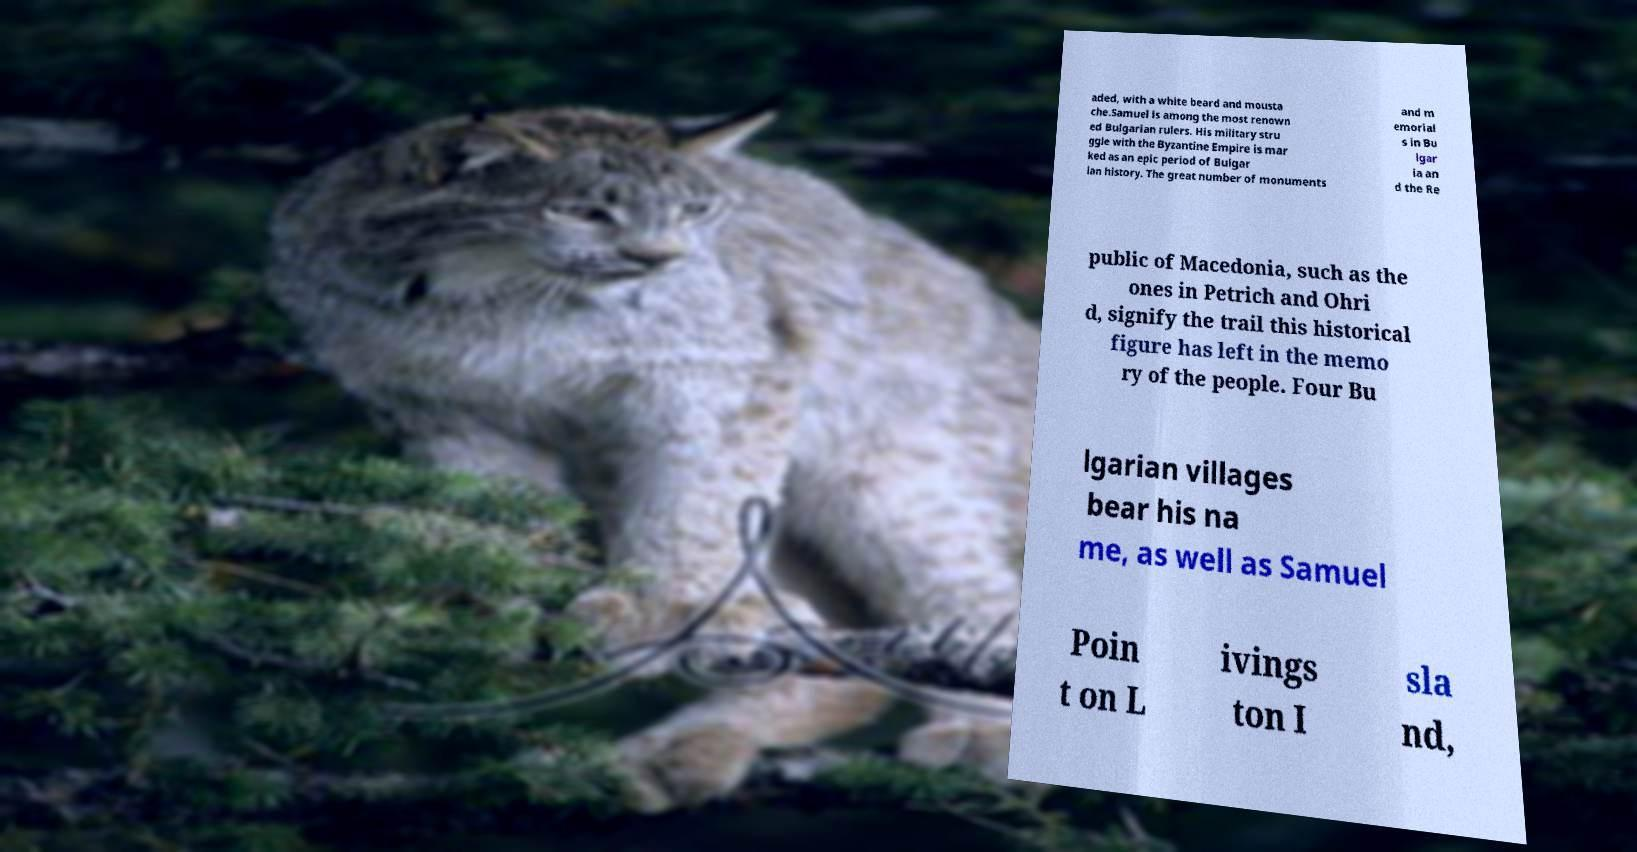I need the written content from this picture converted into text. Can you do that? aded, with a white beard and mousta che.Samuel is among the most renown ed Bulgarian rulers. His military stru ggle with the Byzantine Empire is mar ked as an epic period of Bulgar ian history. The great number of monuments and m emorial s in Bu lgar ia an d the Re public of Macedonia, such as the ones in Petrich and Ohri d, signify the trail this historical figure has left in the memo ry of the people. Four Bu lgarian villages bear his na me, as well as Samuel Poin t on L ivings ton I sla nd, 